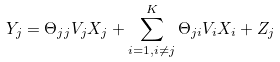Convert formula to latex. <formula><loc_0><loc_0><loc_500><loc_500>Y _ { j } & = \Theta _ { j j } V _ { j } X _ { j } + \sum _ { i = 1 , i \neq j } ^ { K } \Theta _ { j i } V _ { i } X _ { i } + Z _ { j }</formula> 